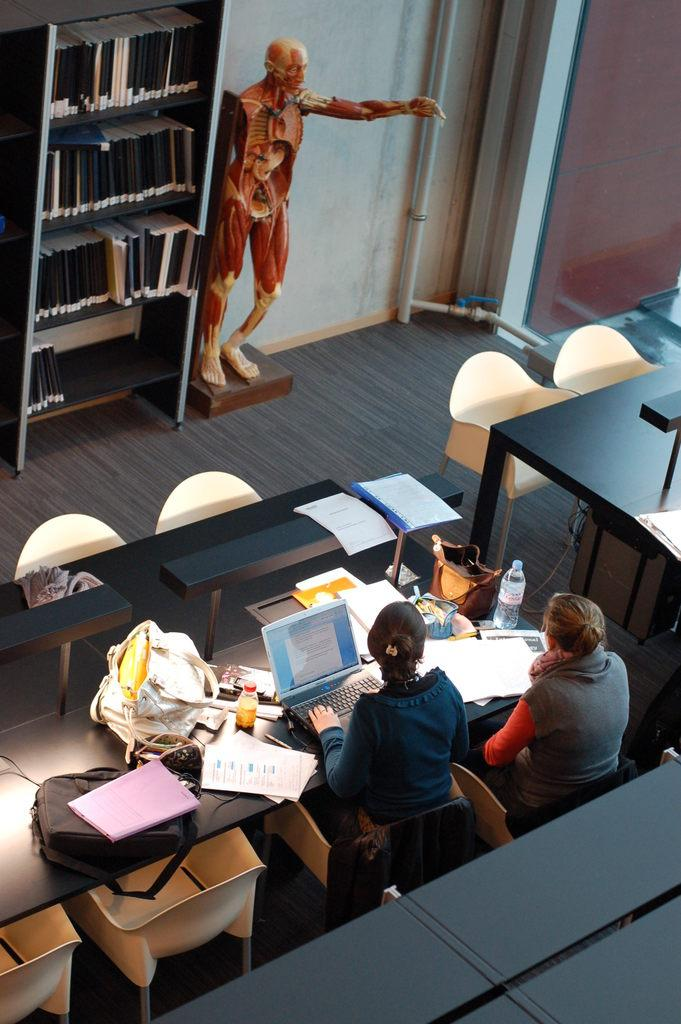How many people are present in the image? There are two persons sitting in the image. What are the two persons doing in the image? The two persons are looking at a laptop. What object is located in the middle of the image? There is a human-shaped doll in the middle of the image. What type of club is the person holding in the image? There is no club present in the image; it features two persons looking at a laptop and a human-shaped doll. 